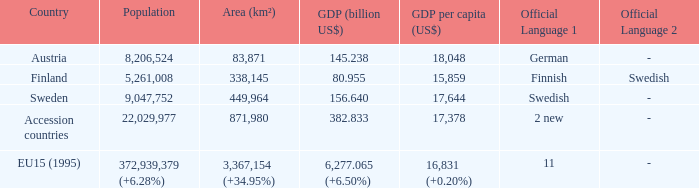Name the area for german 83871.0. 